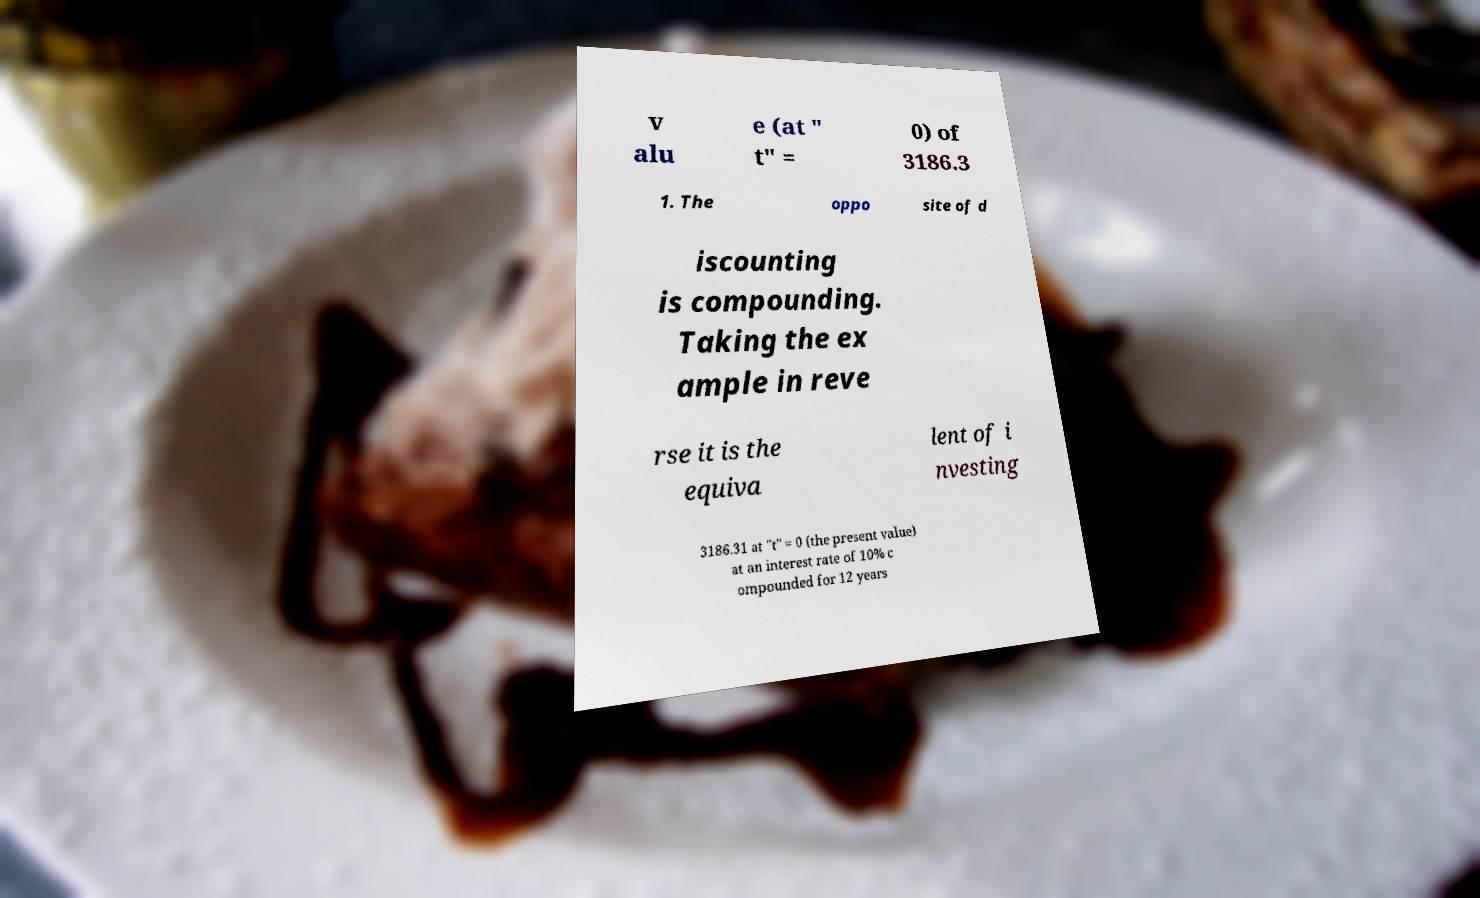For documentation purposes, I need the text within this image transcribed. Could you provide that? v alu e (at " t" = 0) of 3186.3 1. The oppo site of d iscounting is compounding. Taking the ex ample in reve rse it is the equiva lent of i nvesting 3186.31 at "t" = 0 (the present value) at an interest rate of 10% c ompounded for 12 years 